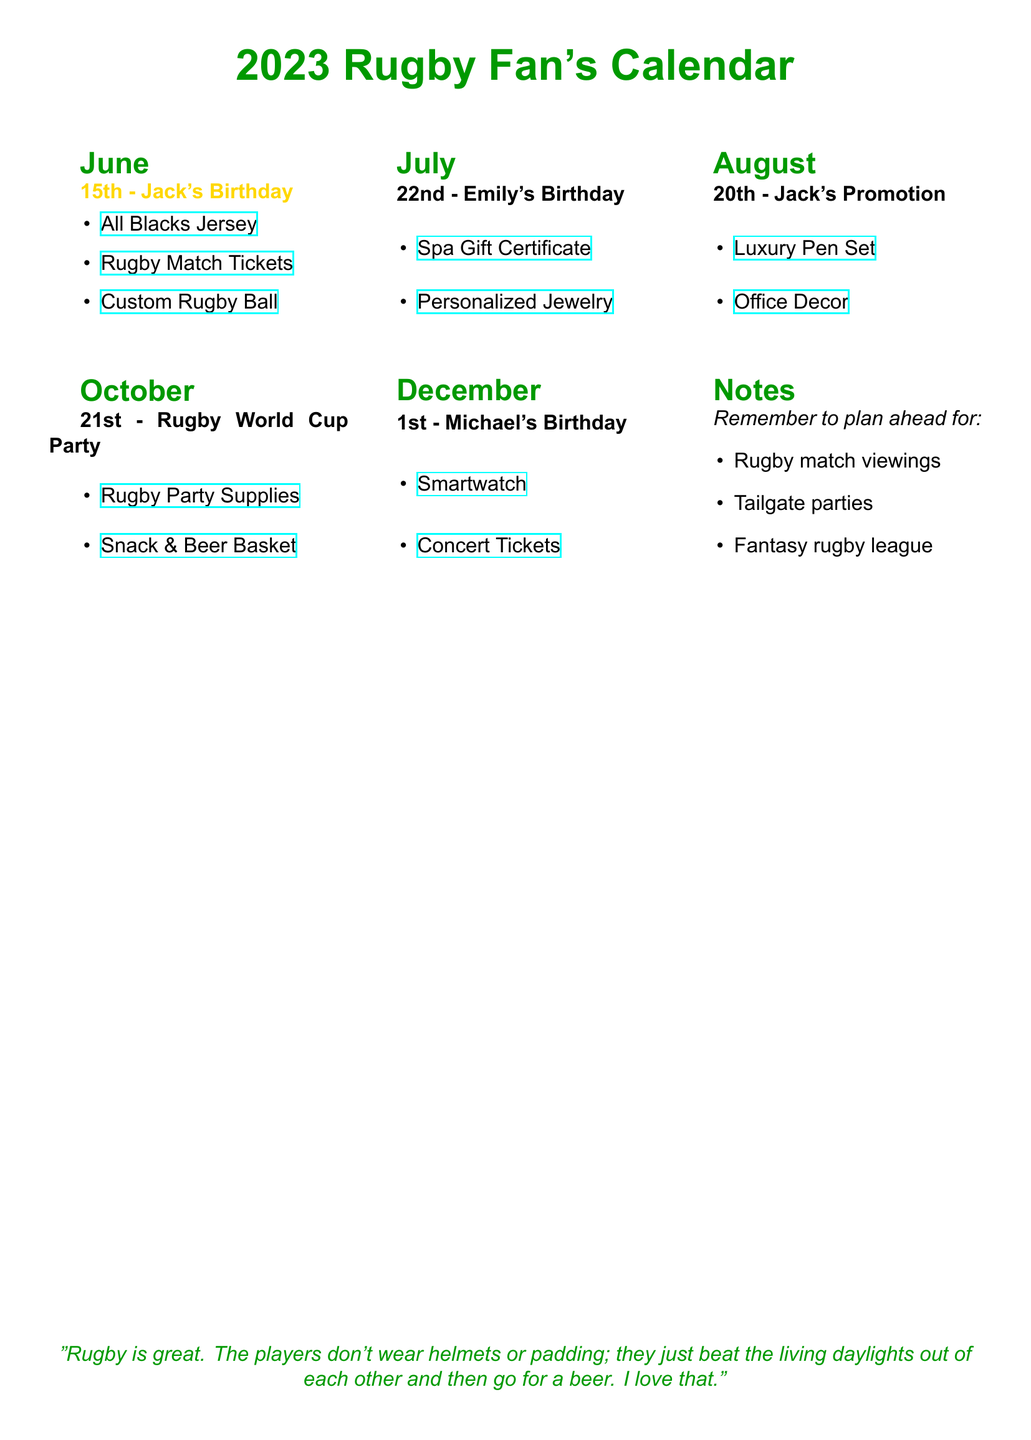What date is Jack's birthday? Jack's birthday is listed on June 15th in the document.
Answer: June 15th What gift ideas are suggested for Jack's birthday? The document lists three gift ideas for Jack's birthday under June 15th.
Answer: All Blacks Jersey, Rugby Match Tickets, Custom Rugby Ball When is Emily's birthday? Emily's birthday is specified in the document as July 22nd.
Answer: July 22nd What special event is noted for August? The document mentions Jack's promotion as a special event in August.
Answer: Jack's Promotion What is included in the gift ideas for Michael's birthday? The document provides two suggestions for Michael's birthday under December 1st.
Answer: Smartwatch, Concert Tickets What party is scheduled for October? The document notes a Rugby World Cup Party on October 21st.
Answer: Rugby World Cup Party How many friends' birthdays are listed in total? The document lists four birthdays, including Jack's, Emily's, and Michael's.
Answer: Four What is one suggestion for planning ahead noted in the document? The document includes planning ahead for one of several activities related to rugby.
Answer: Fantasy rugby league 